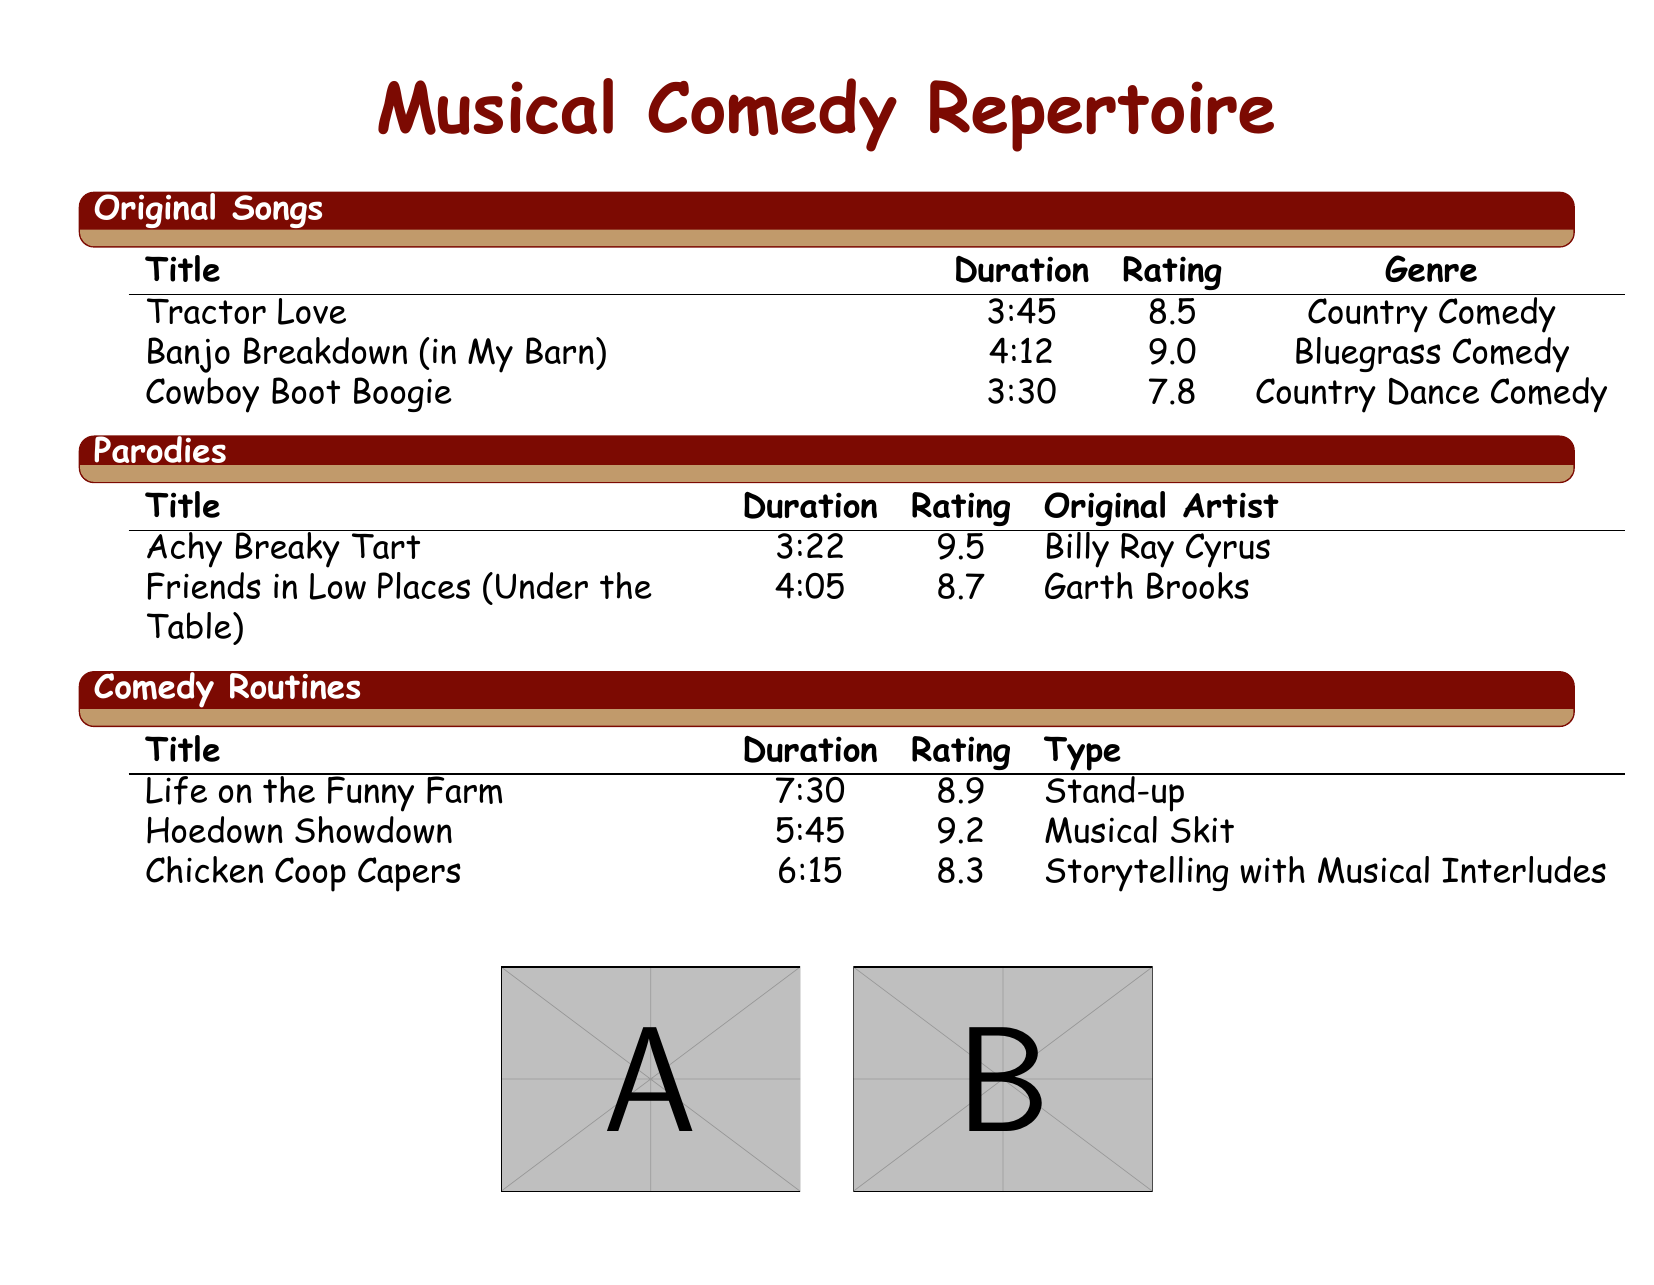What is the title of the original song with the highest rating? The highest rating among original songs is 9.0 for "Banjo Breakdown (in My Barn)."
Answer: Banjo Breakdown (in My Barn) How long is the comedy routine "Life on the Funny Farm"? The document states that "Life on the Funny Farm" has a duration of 7:30 minutes.
Answer: 7:30 Which parody has the longest duration? The longest duration in the parody section is "Friends in Low Places (Under the Table)" at 4:05 minutes.
Answer: Friends in Low Places (Under the Table) What is the genre of "Tractor Love"? The genre of "Tractor Love" listed in the original songs section is Country Comedy.
Answer: Country Comedy What is the average rating of the original songs? The average rating can be calculated from the ratings given for original songs: (8.5 + 9.0 + 7.8) / 3 = 8.433.
Answer: 8.433 How many comedy routines are listed in the document? There are three comedy routines listed in the comedy routines section of the document.
Answer: 3 What type of performance is "Hoedown Showdown"? The document classifies "Hoedown Showdown" as a Musical Skit in the comedy routines section.
Answer: Musical Skit Which original song has the shortest duration? The original song with the shortest duration is "Cowboy Boot Boogie," which lasts 3:30 minutes.
Answer: Cowboy Boot Boogie What rating did "Achy Breaky Tart" receive? "Achy Breaky Tart" has a rating of 9.5 in the parodies section.
Answer: 9.5 